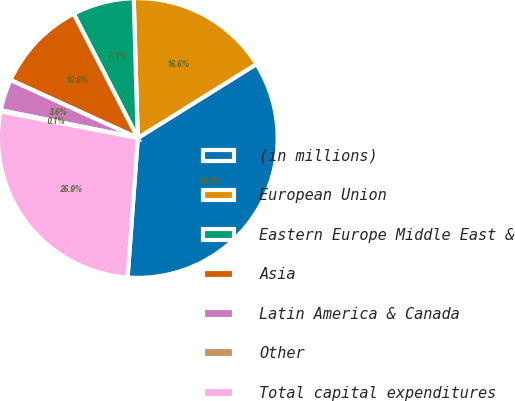<chart> <loc_0><loc_0><loc_500><loc_500><pie_chart><fcel>(in millions)<fcel>European Union<fcel>Eastern Europe Middle East &<fcel>Asia<fcel>Latin America & Canada<fcel>Other<fcel>Total capital expenditures<nl><fcel>35.03%<fcel>16.6%<fcel>7.12%<fcel>10.61%<fcel>3.63%<fcel>0.14%<fcel>26.88%<nl></chart> 